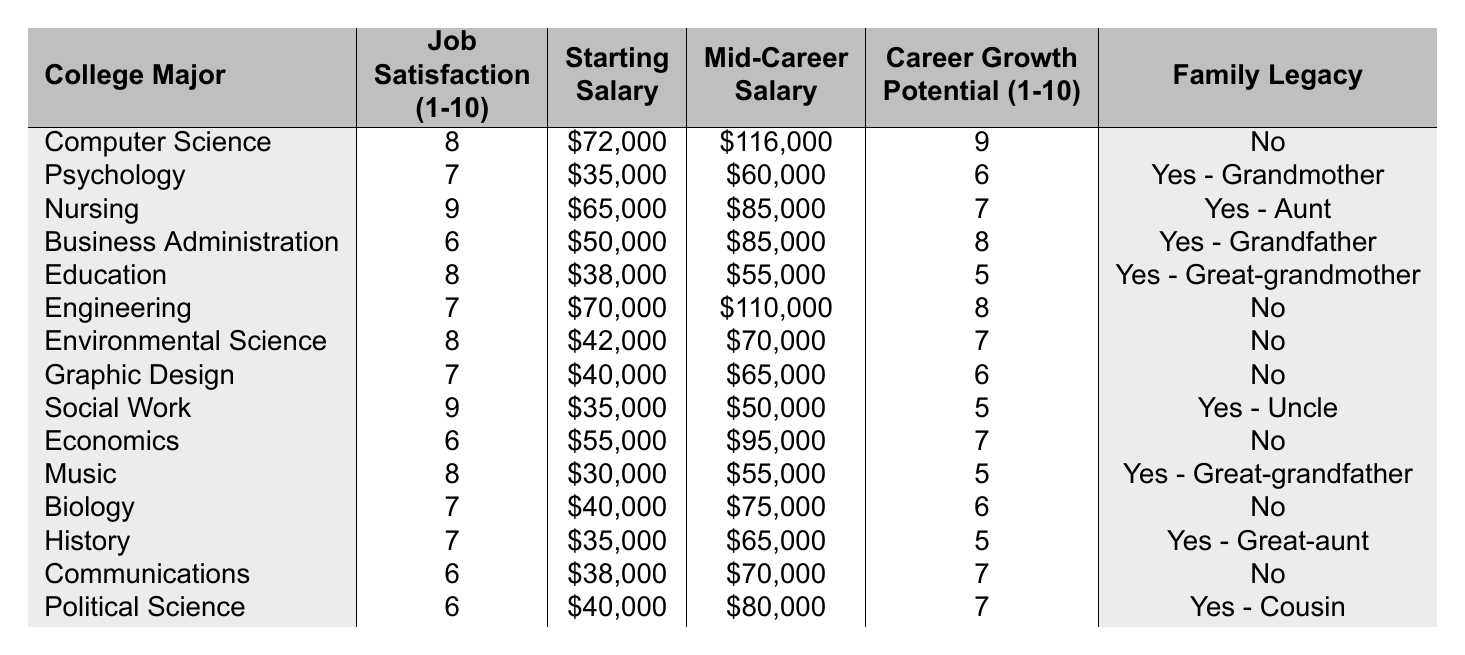What is the highest starting salary among the college majors listed? The table lists starting salaries for various majors, and I will look for the highest value. The highest starting salary is $72,000 for Computer Science.
Answer: $72,000 Which major has the lowest mid-career salary? I will check the mid-career salaries listed in the table. The lowest mid-career salary is $50,000 for Social Work.
Answer: $50,000 What is the job satisfaction rating for Nursing? The table shows that the job satisfaction rating for Nursing is 9 out of 10.
Answer: 9 How many majors have a career growth potential rating of 7 or higher? I will count the majors with a career growth potential of 7 or above from the table. They are Computer Science, Nursing, Business Administration, Engineering, Environmental Science, Economics, and Political Science, giving a total of 7 majors.
Answer: 7 Is there a major that has both high job satisfaction (8 or above) and a family legacy associated with it? I will look at the table for any major that has a job satisfaction of 8 or higher and has a "Yes" under the family legacy column. Nursing is the only major that meets both criteria with a job satisfaction of 9 and a family legacy of "Yes - Aunt."
Answer: Yes, Nursing What is the average starting salary of the majors that have a family legacy? I will first list the starting salaries of majors with a family legacy: Psychology ($35,000), Nursing ($65,000), Business Administration ($50,000), Education ($38,000), Social Work ($35,000), Music ($30,000), History ($35,000), and Political Science ($40,000). Adding these amounts gives $35,000 + $65,000 + $50,000 + $38,000 + $35,000 + $30,000 + $35,000 + $40,000 = $358,000. There are 8 majors, therefore average = $358,000 / 8 = $44,750.
Answer: $44,750 What is the difference in job satisfaction between Computer Science and Graphic Design? The table shows that Computer Science has a job satisfaction of 8, while Graphic Design has 7. The difference is 8 - 7 = 1.
Answer: 1 Which major has the highest career growth potential score? I will check the career growth potential scores and find the highest one. The highest score is 9 for Computer Science.
Answer: 9 How many majors have a starting salary of less than $40,000? I will look through the starting salaries in the table. The majors with starting salaries less than $40,000 are Music ($30,000), Social Work ($35,000), Psychology ($35,000), and Education ($38,000), which totals 4 majors.
Answer: 4 Which major has the highest mid-career salary if we exclude Computer Science? Excluding Computer Science, I will look for the highest mid-career salary among the rest. The highest mid-career salary after excluding Computer Science is $110,000 for Engineering.
Answer: $110,000 